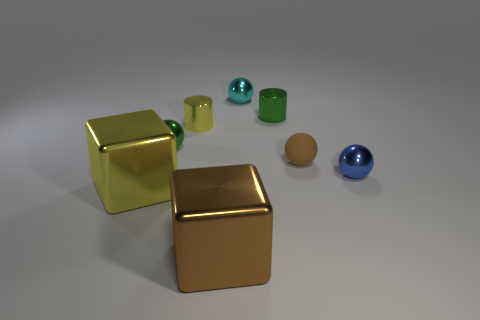What number of other objects are the same color as the tiny rubber sphere?
Your response must be concise. 1. What number of other things are the same material as the blue sphere?
Provide a short and direct response. 6. There is a yellow object that is in front of the blue shiny object; what is its shape?
Make the answer very short. Cube. Is the number of brown rubber balls that are behind the tiny yellow shiny cylinder less than the number of metal balls that are to the right of the small blue shiny thing?
Provide a succinct answer. No. Do the brown rubber ball and the green shiny thing behind the yellow cylinder have the same size?
Ensure brevity in your answer.  Yes. How many brown shiny objects are the same size as the yellow shiny cube?
Provide a short and direct response. 1. What is the color of the big object that is the same material as the big yellow block?
Your answer should be compact. Brown. Are there more large purple cylinders than small brown rubber spheres?
Offer a terse response. No. Does the tiny yellow thing have the same material as the small cyan ball?
Provide a succinct answer. Yes. What shape is the small yellow thing that is made of the same material as the green cylinder?
Offer a terse response. Cylinder. 